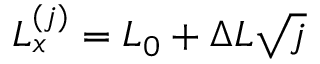<formula> <loc_0><loc_0><loc_500><loc_500>L _ { x } ^ { ( j ) } = L _ { 0 } + \Delta L \sqrt { j }</formula> 